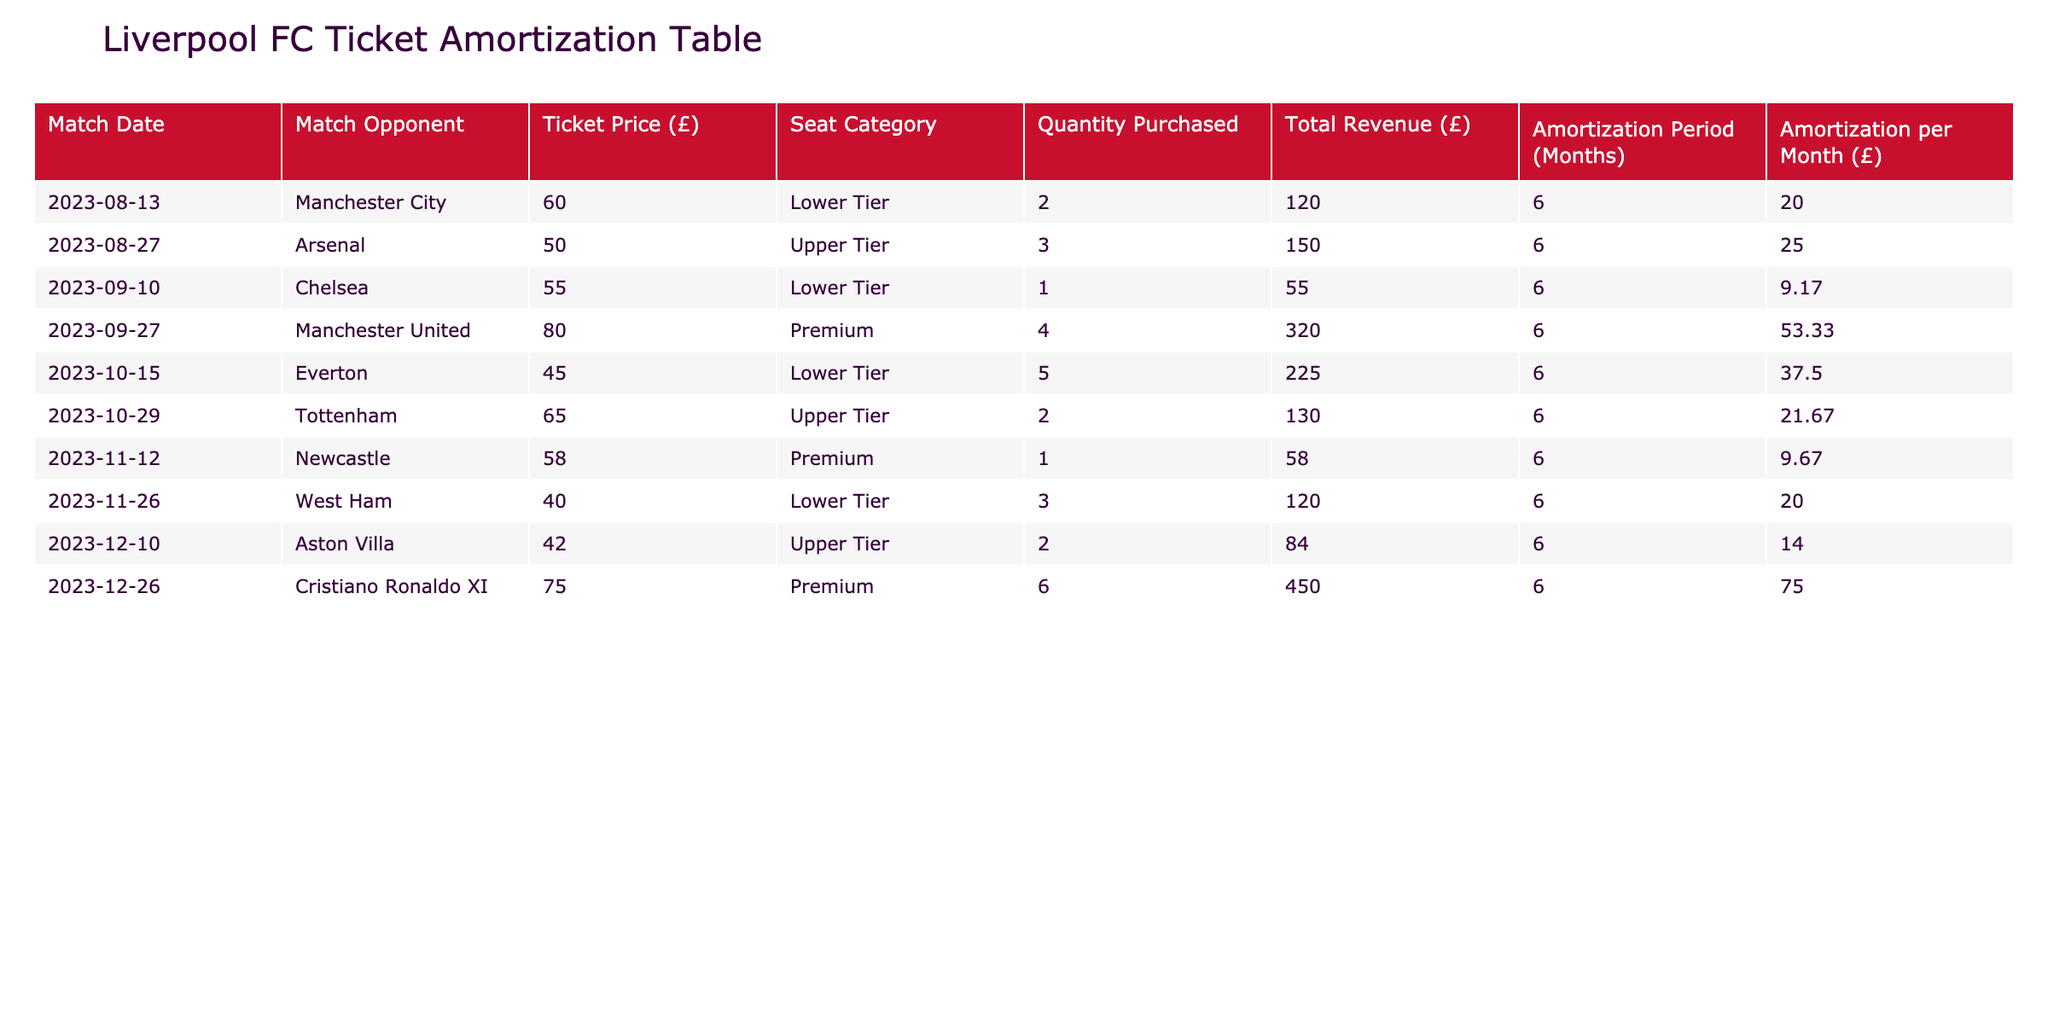What is the total revenue generated from the match against Manchester United? The total revenue for the Manchester United match on September 27 is explicitly listed in the table as £320.
Answer: £320 How much is the amortization per month for the ticket purchases for the Tottenham match? The table shows that the amortization per month for the Tottenham match on October 29 is £21.67.
Answer: £21.67 Which match had the highest ticket price and what was that price? The table reveals that the match against Manchester United had the highest ticket price at £80.
Answer: £80 What is the total revenue generated from all matches in the table? To find the total revenue, I sum the total revenue values of all matches: 120 + 150 + 55 + 320 + 225 + 130 + 58 + 120 + 84 + 450 = £1,590.
Answer: £1,590 Is there a match where the amortization period is longer than 6 months? The table clearly states that all matches have an amortization period of 6 months, meaning the answer is no.
Answer: No What is the average ticket price across all matches? To find the average ticket price, sum the ticket prices: 60 + 50 + 55 + 80 + 45 + 65 + 58 + 40 + 42 + 75 = £600, then divide by the number of matches (10): 600 / 10 = £60.
Answer: £60 What percentage of the total revenue comes from the match against Cristiano Ronaldo XI? The revenue from the Cristiano Ronaldo XI match is £450. The total revenue is £1,590. To find the percentage: (450 / 1590) * 100 = 28.4%.
Answer: 28.4% Was there any match where the quantity purchased was more than 5 tickets? Upon examining the table, the Everton match had 5 tickets purchased, and no match has more than that. Therefore, the answer is no.
Answer: No Which match had the lowest total revenue and what was that revenue? Looking at the total revenue for each match, the Chelsea match on September 10 had the lowest total revenue at £55.
Answer: £55 